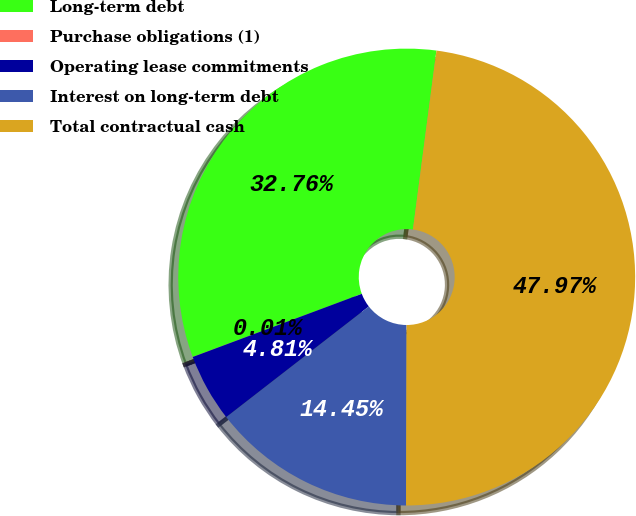Convert chart. <chart><loc_0><loc_0><loc_500><loc_500><pie_chart><fcel>Long-term debt<fcel>Purchase obligations (1)<fcel>Operating lease commitments<fcel>Interest on long-term debt<fcel>Total contractual cash<nl><fcel>32.76%<fcel>0.01%<fcel>4.81%<fcel>14.45%<fcel>47.97%<nl></chart> 